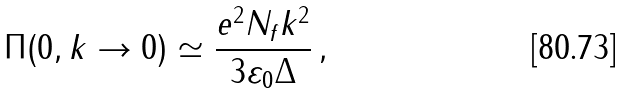<formula> <loc_0><loc_0><loc_500><loc_500>\Pi ( 0 , k \to 0 ) \simeq \frac { e ^ { 2 } N _ { f } k ^ { 2 } } { 3 \varepsilon _ { 0 } \Delta } \, ,</formula> 